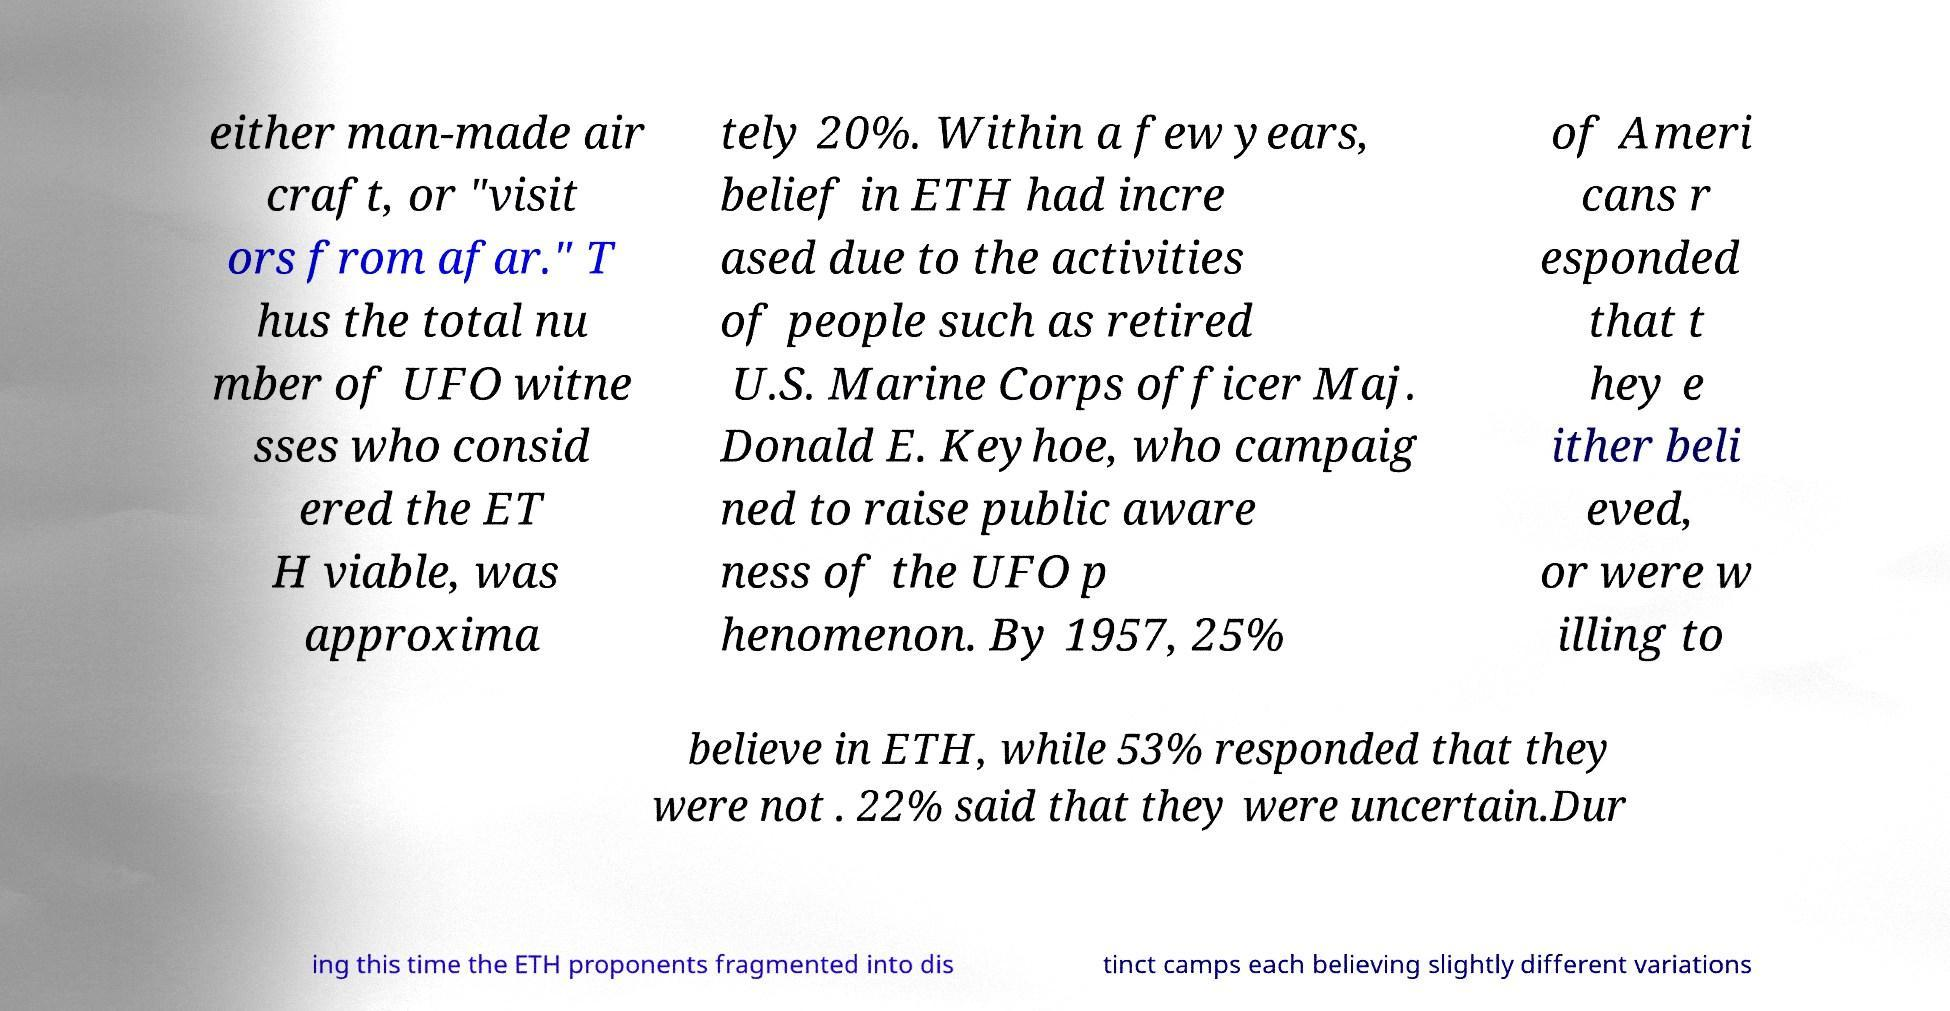For documentation purposes, I need the text within this image transcribed. Could you provide that? either man-made air craft, or "visit ors from afar." T hus the total nu mber of UFO witne sses who consid ered the ET H viable, was approxima tely 20%. Within a few years, belief in ETH had incre ased due to the activities of people such as retired U.S. Marine Corps officer Maj. Donald E. Keyhoe, who campaig ned to raise public aware ness of the UFO p henomenon. By 1957, 25% of Ameri cans r esponded that t hey e ither beli eved, or were w illing to believe in ETH, while 53% responded that they were not . 22% said that they were uncertain.Dur ing this time the ETH proponents fragmented into dis tinct camps each believing slightly different variations 